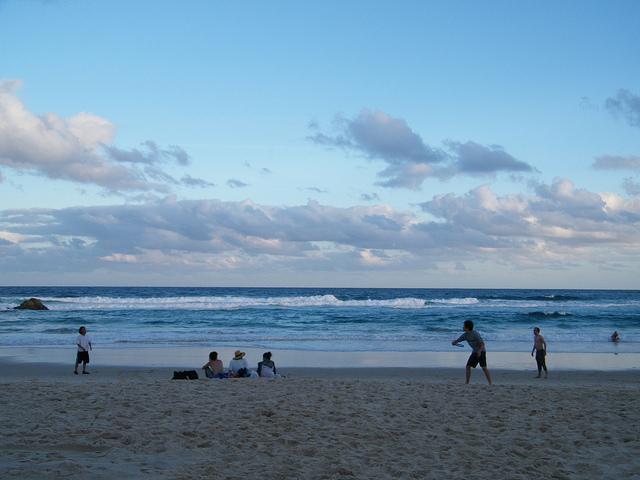How many people are visible in this scene?
Give a very brief answer. 7. 